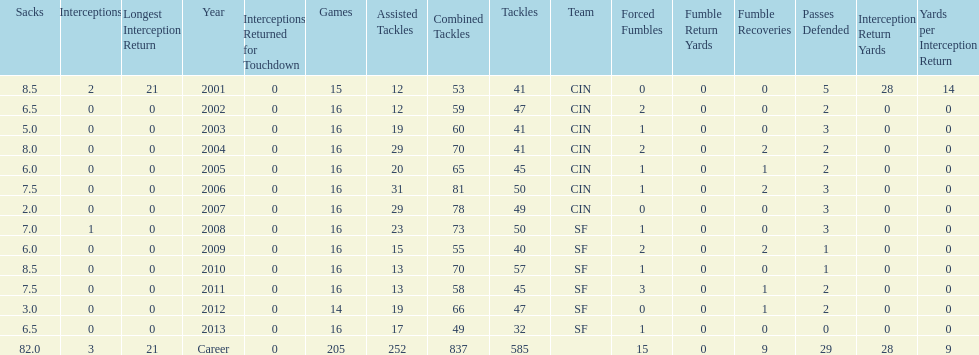How many years did he play in less than 16 games? 2. 